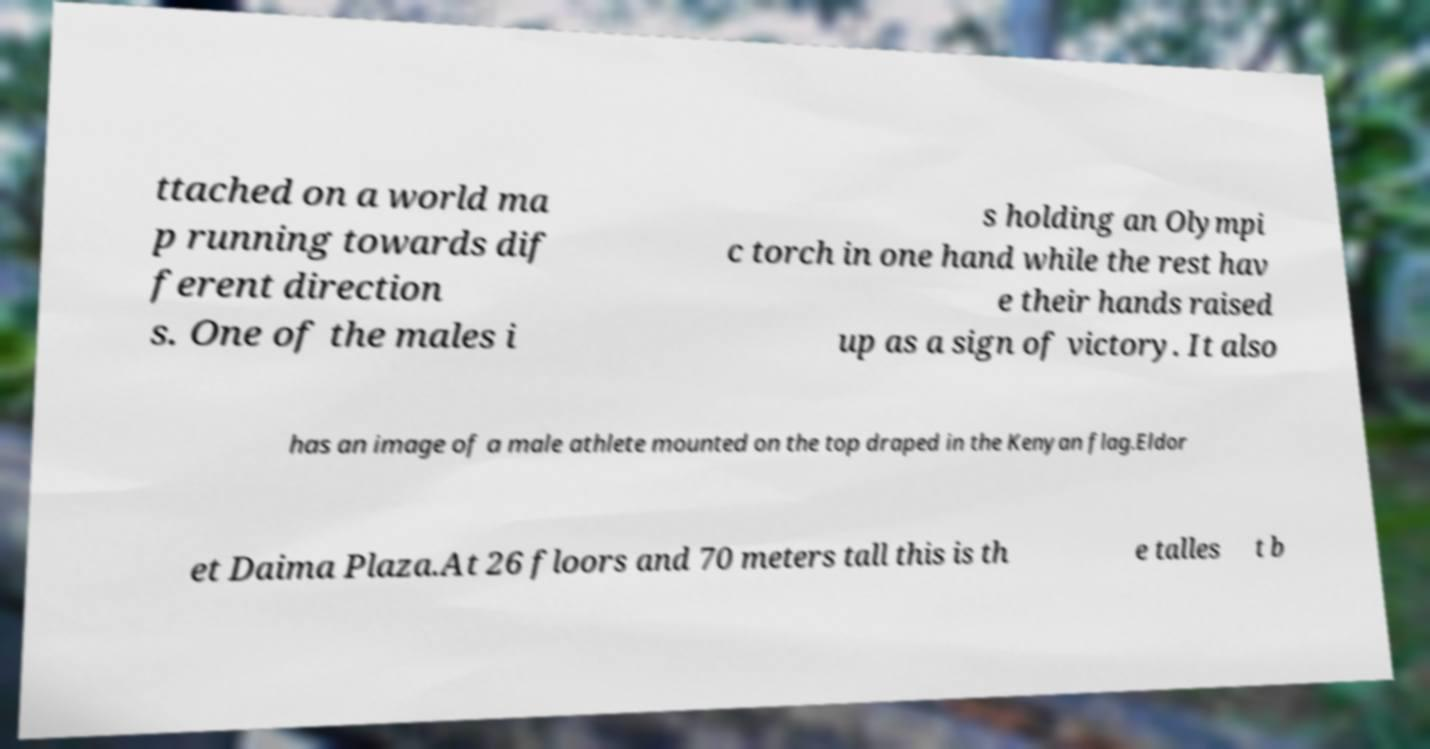Please identify and transcribe the text found in this image. ttached on a world ma p running towards dif ferent direction s. One of the males i s holding an Olympi c torch in one hand while the rest hav e their hands raised up as a sign of victory. It also has an image of a male athlete mounted on the top draped in the Kenyan flag.Eldor et Daima Plaza.At 26 floors and 70 meters tall this is th e talles t b 